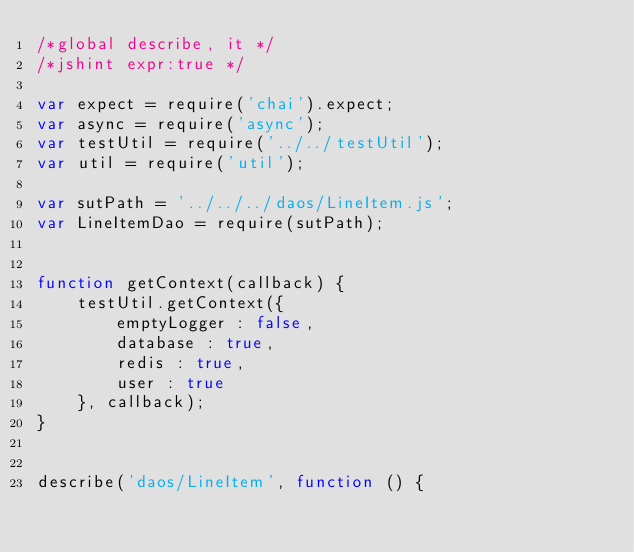Convert code to text. <code><loc_0><loc_0><loc_500><loc_500><_JavaScript_>/*global describe, it */
/*jshint expr:true */

var expect = require('chai').expect;
var async = require('async');
var testUtil = require('../../testUtil');
var util = require('util');

var sutPath = '../../../daos/LineItem.js';
var LineItemDao = require(sutPath);


function getContext(callback) {
    testUtil.getContext({
        emptyLogger : false,
        database : true,
        redis : true,
        user : true
    }, callback);
}


describe('daos/LineItem', function () {</code> 